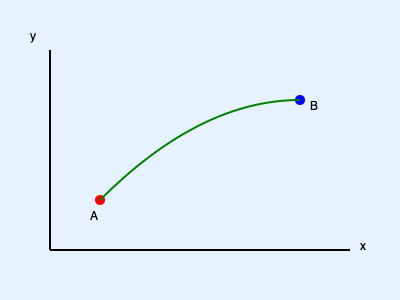In a sports simulation game, a player at point A (100, 50) needs to intercept a ball moving along a parabolic path from A to B (300, 150). The ball's path is described by the equation $y = -0.005x^2 + 1.5x - 50$. At what point (x, y) should the player aim to intercept the ball, assuming they can move in a straight line at a constant speed? To find the optimal interception point, we need to follow these steps:

1) The player's straight-line path and the ball's parabolic path should intersect at the interception point. This point will minimize the time for both the player and the ball to reach it.

2) The player's path can be described by a linear equation:
   $y = mx + b$, where $m$ is the slope and $b$ is the y-intercept.

3) The ball's path is given by:
   $y = -0.005x^2 + 1.5x - 50$

4) At the interception point, these equations should be equal. So we can set up the equation:
   $mx + b = -0.005x^2 + 1.5x - 50$

5) We also know that this line must pass through point A (100, 50). We can use this to find $b$:
   $50 = 100m + b$
   $b = 50 - 100m$

6) Substituting this back into our equation:
   $mx + (50 - 100m) = -0.005x^2 + 1.5x - 50$

7) Rearranging:
   $0.005x^2 + (m - 1.5)x + (100m) = 0$

8) This is a quadratic equation. For the optimal interception point, this equation should have exactly one solution (tangent point). This occurs when the discriminant is zero:
   $b^2 - 4ac = 0$
   $(m - 1.5)^2 - 4(0.005)(100m) = 0$

9) Solving this equation for $m$:
   $m \approx 0.6$

10) Now we can find $b$:
    $b = 50 - 100(0.6) = -10$

11) Our line equation is now:
    $y = 0.6x - 10$

12) To find the interception point, we solve:
    $0.6x - 10 = -0.005x^2 + 1.5x - 50$
    $0.005x^2 - 0.9x + 40 = 0$

13) Solving this quadratic equation:
    $x \approx 200$

14) Substituting back to find $y$:
    $y = 0.6(200) - 10 = 110$

Therefore, the optimal interception point is approximately (200, 110).
Answer: (200, 110) 